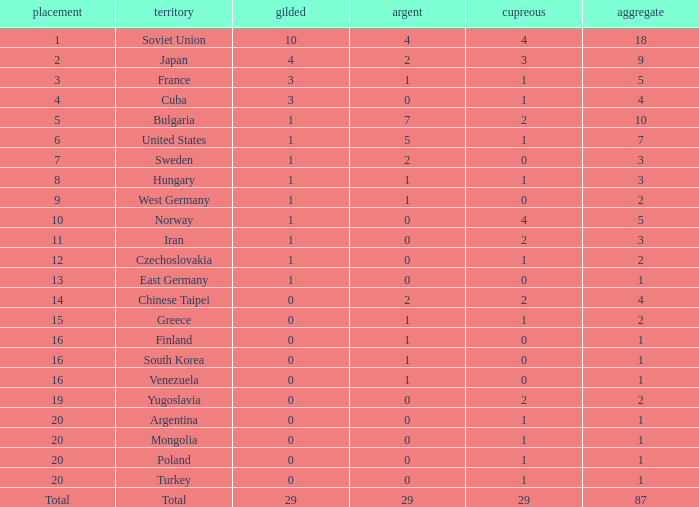What is the average number of bronze medals for total of all nations? 29.0. 